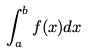Convert formula to latex. <formula><loc_0><loc_0><loc_500><loc_500>\int _ { a } ^ { b } f ( x ) d x</formula> 